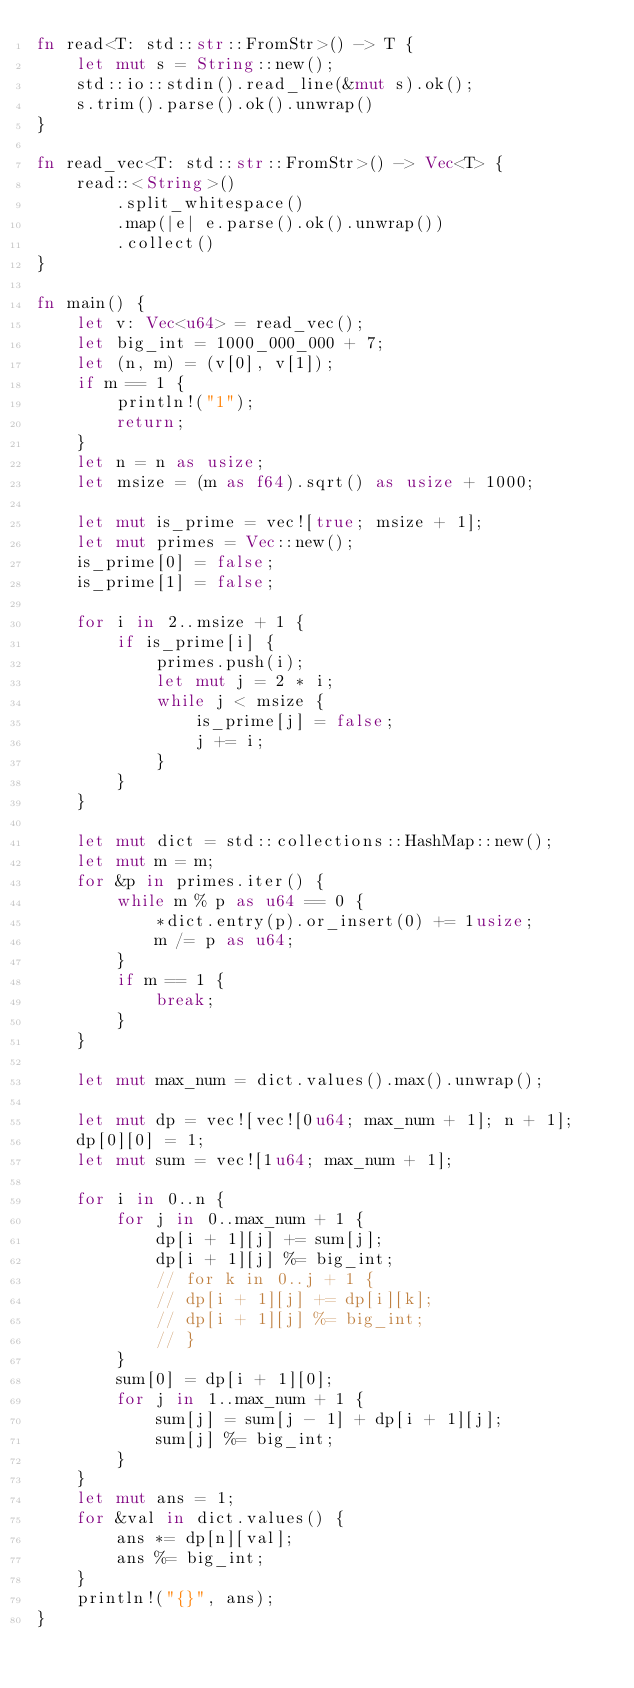<code> <loc_0><loc_0><loc_500><loc_500><_Rust_>fn read<T: std::str::FromStr>() -> T {
    let mut s = String::new();
    std::io::stdin().read_line(&mut s).ok();
    s.trim().parse().ok().unwrap()
}

fn read_vec<T: std::str::FromStr>() -> Vec<T> {
    read::<String>()
        .split_whitespace()
        .map(|e| e.parse().ok().unwrap())
        .collect()
}

fn main() {
    let v: Vec<u64> = read_vec();
    let big_int = 1000_000_000 + 7;
    let (n, m) = (v[0], v[1]);
    if m == 1 {
        println!("1");
        return;
    }
    let n = n as usize;
    let msize = (m as f64).sqrt() as usize + 1000;

    let mut is_prime = vec![true; msize + 1];
    let mut primes = Vec::new();
    is_prime[0] = false;
    is_prime[1] = false;

    for i in 2..msize + 1 {
        if is_prime[i] {
            primes.push(i);
            let mut j = 2 * i;
            while j < msize {
                is_prime[j] = false;
                j += i;
            }
        }
    }

    let mut dict = std::collections::HashMap::new();
    let mut m = m;
    for &p in primes.iter() {
        while m % p as u64 == 0 {
            *dict.entry(p).or_insert(0) += 1usize;
            m /= p as u64;
        }
        if m == 1 {
            break;
        }
    }

    let mut max_num = dict.values().max().unwrap();

    let mut dp = vec![vec![0u64; max_num + 1]; n + 1];
    dp[0][0] = 1;
    let mut sum = vec![1u64; max_num + 1];

    for i in 0..n {
        for j in 0..max_num + 1 {
            dp[i + 1][j] += sum[j];
            dp[i + 1][j] %= big_int;
            // for k in 0..j + 1 {
            // dp[i + 1][j] += dp[i][k];
            // dp[i + 1][j] %= big_int;
            // }
        }
        sum[0] = dp[i + 1][0];
        for j in 1..max_num + 1 {
            sum[j] = sum[j - 1] + dp[i + 1][j];
            sum[j] %= big_int;
        }
    }
    let mut ans = 1;
    for &val in dict.values() {
        ans *= dp[n][val];
        ans %= big_int;
    }
    println!("{}", ans);
}
</code> 